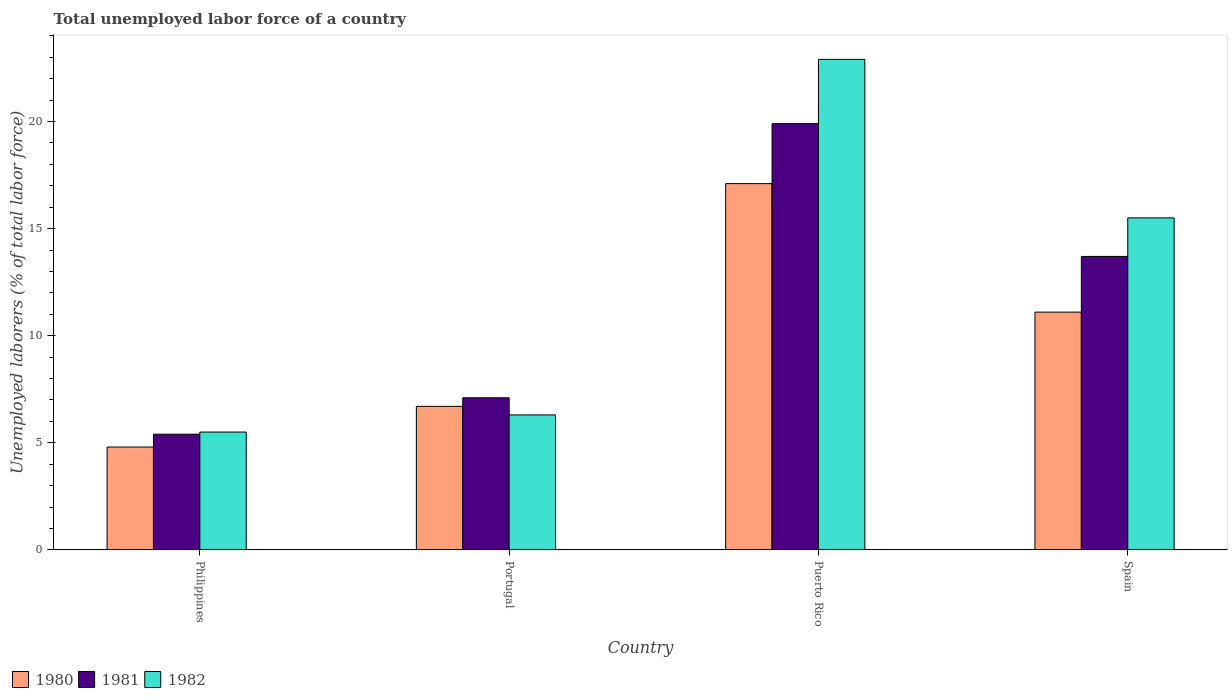How many different coloured bars are there?
Make the answer very short. 3. Are the number of bars on each tick of the X-axis equal?
Provide a short and direct response. Yes. How many bars are there on the 2nd tick from the left?
Your answer should be very brief. 3. What is the label of the 4th group of bars from the left?
Provide a short and direct response. Spain. In how many cases, is the number of bars for a given country not equal to the number of legend labels?
Make the answer very short. 0. Across all countries, what is the maximum total unemployed labor force in 1981?
Ensure brevity in your answer.  19.9. Across all countries, what is the minimum total unemployed labor force in 1980?
Provide a short and direct response. 4.8. In which country was the total unemployed labor force in 1981 maximum?
Ensure brevity in your answer.  Puerto Rico. In which country was the total unemployed labor force in 1981 minimum?
Keep it short and to the point. Philippines. What is the total total unemployed labor force in 1982 in the graph?
Your answer should be very brief. 50.2. What is the difference between the total unemployed labor force in 1980 in Portugal and that in Puerto Rico?
Provide a short and direct response. -10.4. What is the difference between the total unemployed labor force in 1980 in Philippines and the total unemployed labor force in 1981 in Portugal?
Make the answer very short. -2.3. What is the average total unemployed labor force in 1981 per country?
Make the answer very short. 11.52. What is the difference between the total unemployed labor force of/in 1982 and total unemployed labor force of/in 1981 in Spain?
Your answer should be very brief. 1.8. In how many countries, is the total unemployed labor force in 1980 greater than 12 %?
Ensure brevity in your answer.  1. What is the ratio of the total unemployed labor force in 1981 in Philippines to that in Puerto Rico?
Your answer should be compact. 0.27. Is the difference between the total unemployed labor force in 1982 in Philippines and Spain greater than the difference between the total unemployed labor force in 1981 in Philippines and Spain?
Offer a very short reply. No. What is the difference between the highest and the second highest total unemployed labor force in 1981?
Make the answer very short. 6.2. What is the difference between the highest and the lowest total unemployed labor force in 1981?
Provide a short and direct response. 14.5. What does the 3rd bar from the left in Portugal represents?
Make the answer very short. 1982. How many bars are there?
Ensure brevity in your answer.  12. Are all the bars in the graph horizontal?
Ensure brevity in your answer.  No. What is the difference between two consecutive major ticks on the Y-axis?
Give a very brief answer. 5. Are the values on the major ticks of Y-axis written in scientific E-notation?
Offer a terse response. No. Does the graph contain grids?
Provide a succinct answer. No. How many legend labels are there?
Keep it short and to the point. 3. How are the legend labels stacked?
Provide a succinct answer. Horizontal. What is the title of the graph?
Provide a short and direct response. Total unemployed labor force of a country. What is the label or title of the X-axis?
Make the answer very short. Country. What is the label or title of the Y-axis?
Ensure brevity in your answer.  Unemployed laborers (% of total labor force). What is the Unemployed laborers (% of total labor force) of 1980 in Philippines?
Offer a terse response. 4.8. What is the Unemployed laborers (% of total labor force) of 1981 in Philippines?
Offer a terse response. 5.4. What is the Unemployed laborers (% of total labor force) in 1980 in Portugal?
Make the answer very short. 6.7. What is the Unemployed laborers (% of total labor force) of 1981 in Portugal?
Your response must be concise. 7.1. What is the Unemployed laborers (% of total labor force) of 1982 in Portugal?
Your answer should be compact. 6.3. What is the Unemployed laborers (% of total labor force) in 1980 in Puerto Rico?
Provide a succinct answer. 17.1. What is the Unemployed laborers (% of total labor force) of 1981 in Puerto Rico?
Your answer should be compact. 19.9. What is the Unemployed laborers (% of total labor force) in 1982 in Puerto Rico?
Give a very brief answer. 22.9. What is the Unemployed laborers (% of total labor force) of 1980 in Spain?
Your response must be concise. 11.1. What is the Unemployed laborers (% of total labor force) in 1981 in Spain?
Your answer should be compact. 13.7. Across all countries, what is the maximum Unemployed laborers (% of total labor force) of 1980?
Your answer should be very brief. 17.1. Across all countries, what is the maximum Unemployed laborers (% of total labor force) of 1981?
Ensure brevity in your answer.  19.9. Across all countries, what is the maximum Unemployed laborers (% of total labor force) in 1982?
Your response must be concise. 22.9. Across all countries, what is the minimum Unemployed laborers (% of total labor force) in 1980?
Offer a terse response. 4.8. Across all countries, what is the minimum Unemployed laborers (% of total labor force) in 1981?
Give a very brief answer. 5.4. What is the total Unemployed laborers (% of total labor force) in 1980 in the graph?
Your response must be concise. 39.7. What is the total Unemployed laborers (% of total labor force) in 1981 in the graph?
Your answer should be very brief. 46.1. What is the total Unemployed laborers (% of total labor force) of 1982 in the graph?
Keep it short and to the point. 50.2. What is the difference between the Unemployed laborers (% of total labor force) of 1980 in Philippines and that in Portugal?
Make the answer very short. -1.9. What is the difference between the Unemployed laborers (% of total labor force) of 1981 in Philippines and that in Portugal?
Give a very brief answer. -1.7. What is the difference between the Unemployed laborers (% of total labor force) in 1981 in Philippines and that in Puerto Rico?
Your answer should be very brief. -14.5. What is the difference between the Unemployed laborers (% of total labor force) of 1982 in Philippines and that in Puerto Rico?
Offer a very short reply. -17.4. What is the difference between the Unemployed laborers (% of total labor force) of 1980 in Philippines and that in Spain?
Ensure brevity in your answer.  -6.3. What is the difference between the Unemployed laborers (% of total labor force) in 1980 in Portugal and that in Puerto Rico?
Offer a very short reply. -10.4. What is the difference between the Unemployed laborers (% of total labor force) in 1982 in Portugal and that in Puerto Rico?
Provide a succinct answer. -16.6. What is the difference between the Unemployed laborers (% of total labor force) of 1980 in Portugal and that in Spain?
Provide a short and direct response. -4.4. What is the difference between the Unemployed laborers (% of total labor force) in 1981 in Portugal and that in Spain?
Provide a succinct answer. -6.6. What is the difference between the Unemployed laborers (% of total labor force) in 1980 in Puerto Rico and that in Spain?
Your answer should be compact. 6. What is the difference between the Unemployed laborers (% of total labor force) of 1981 in Puerto Rico and that in Spain?
Your response must be concise. 6.2. What is the difference between the Unemployed laborers (% of total labor force) of 1982 in Puerto Rico and that in Spain?
Ensure brevity in your answer.  7.4. What is the difference between the Unemployed laborers (% of total labor force) in 1980 in Philippines and the Unemployed laborers (% of total labor force) in 1981 in Puerto Rico?
Your answer should be compact. -15.1. What is the difference between the Unemployed laborers (% of total labor force) of 1980 in Philippines and the Unemployed laborers (% of total labor force) of 1982 in Puerto Rico?
Offer a terse response. -18.1. What is the difference between the Unemployed laborers (% of total labor force) of 1981 in Philippines and the Unemployed laborers (% of total labor force) of 1982 in Puerto Rico?
Your response must be concise. -17.5. What is the difference between the Unemployed laborers (% of total labor force) of 1980 in Philippines and the Unemployed laborers (% of total labor force) of 1981 in Spain?
Provide a succinct answer. -8.9. What is the difference between the Unemployed laborers (% of total labor force) of 1980 in Philippines and the Unemployed laborers (% of total labor force) of 1982 in Spain?
Offer a terse response. -10.7. What is the difference between the Unemployed laborers (% of total labor force) of 1981 in Philippines and the Unemployed laborers (% of total labor force) of 1982 in Spain?
Your response must be concise. -10.1. What is the difference between the Unemployed laborers (% of total labor force) in 1980 in Portugal and the Unemployed laborers (% of total labor force) in 1981 in Puerto Rico?
Offer a very short reply. -13.2. What is the difference between the Unemployed laborers (% of total labor force) in 1980 in Portugal and the Unemployed laborers (% of total labor force) in 1982 in Puerto Rico?
Your response must be concise. -16.2. What is the difference between the Unemployed laborers (% of total labor force) of 1981 in Portugal and the Unemployed laborers (% of total labor force) of 1982 in Puerto Rico?
Your response must be concise. -15.8. What is the difference between the Unemployed laborers (% of total labor force) of 1980 in Portugal and the Unemployed laborers (% of total labor force) of 1981 in Spain?
Your answer should be very brief. -7. What is the difference between the Unemployed laborers (% of total labor force) in 1981 in Portugal and the Unemployed laborers (% of total labor force) in 1982 in Spain?
Your response must be concise. -8.4. What is the difference between the Unemployed laborers (% of total labor force) of 1980 in Puerto Rico and the Unemployed laborers (% of total labor force) of 1981 in Spain?
Make the answer very short. 3.4. What is the average Unemployed laborers (% of total labor force) in 1980 per country?
Provide a succinct answer. 9.93. What is the average Unemployed laborers (% of total labor force) in 1981 per country?
Offer a very short reply. 11.53. What is the average Unemployed laborers (% of total labor force) in 1982 per country?
Provide a short and direct response. 12.55. What is the difference between the Unemployed laborers (% of total labor force) of 1980 and Unemployed laborers (% of total labor force) of 1981 in Philippines?
Provide a succinct answer. -0.6. What is the difference between the Unemployed laborers (% of total labor force) of 1980 and Unemployed laborers (% of total labor force) of 1982 in Philippines?
Offer a terse response. -0.7. What is the difference between the Unemployed laborers (% of total labor force) of 1981 and Unemployed laborers (% of total labor force) of 1982 in Philippines?
Your answer should be compact. -0.1. What is the difference between the Unemployed laborers (% of total labor force) in 1981 and Unemployed laborers (% of total labor force) in 1982 in Puerto Rico?
Ensure brevity in your answer.  -3. What is the difference between the Unemployed laborers (% of total labor force) in 1981 and Unemployed laborers (% of total labor force) in 1982 in Spain?
Your response must be concise. -1.8. What is the ratio of the Unemployed laborers (% of total labor force) in 1980 in Philippines to that in Portugal?
Provide a short and direct response. 0.72. What is the ratio of the Unemployed laborers (% of total labor force) of 1981 in Philippines to that in Portugal?
Provide a short and direct response. 0.76. What is the ratio of the Unemployed laborers (% of total labor force) of 1982 in Philippines to that in Portugal?
Your answer should be very brief. 0.87. What is the ratio of the Unemployed laborers (% of total labor force) in 1980 in Philippines to that in Puerto Rico?
Your response must be concise. 0.28. What is the ratio of the Unemployed laborers (% of total labor force) of 1981 in Philippines to that in Puerto Rico?
Give a very brief answer. 0.27. What is the ratio of the Unemployed laborers (% of total labor force) in 1982 in Philippines to that in Puerto Rico?
Offer a terse response. 0.24. What is the ratio of the Unemployed laborers (% of total labor force) in 1980 in Philippines to that in Spain?
Your answer should be very brief. 0.43. What is the ratio of the Unemployed laborers (% of total labor force) of 1981 in Philippines to that in Spain?
Make the answer very short. 0.39. What is the ratio of the Unemployed laborers (% of total labor force) in 1982 in Philippines to that in Spain?
Ensure brevity in your answer.  0.35. What is the ratio of the Unemployed laborers (% of total labor force) of 1980 in Portugal to that in Puerto Rico?
Your answer should be compact. 0.39. What is the ratio of the Unemployed laborers (% of total labor force) in 1981 in Portugal to that in Puerto Rico?
Offer a terse response. 0.36. What is the ratio of the Unemployed laborers (% of total labor force) in 1982 in Portugal to that in Puerto Rico?
Keep it short and to the point. 0.28. What is the ratio of the Unemployed laborers (% of total labor force) of 1980 in Portugal to that in Spain?
Your answer should be compact. 0.6. What is the ratio of the Unemployed laborers (% of total labor force) of 1981 in Portugal to that in Spain?
Provide a short and direct response. 0.52. What is the ratio of the Unemployed laborers (% of total labor force) in 1982 in Portugal to that in Spain?
Provide a succinct answer. 0.41. What is the ratio of the Unemployed laborers (% of total labor force) in 1980 in Puerto Rico to that in Spain?
Offer a very short reply. 1.54. What is the ratio of the Unemployed laborers (% of total labor force) of 1981 in Puerto Rico to that in Spain?
Your answer should be very brief. 1.45. What is the ratio of the Unemployed laborers (% of total labor force) in 1982 in Puerto Rico to that in Spain?
Provide a short and direct response. 1.48. What is the difference between the highest and the second highest Unemployed laborers (% of total labor force) in 1981?
Provide a succinct answer. 6.2. What is the difference between the highest and the second highest Unemployed laborers (% of total labor force) in 1982?
Provide a short and direct response. 7.4. What is the difference between the highest and the lowest Unemployed laborers (% of total labor force) in 1980?
Make the answer very short. 12.3. What is the difference between the highest and the lowest Unemployed laborers (% of total labor force) of 1981?
Keep it short and to the point. 14.5. What is the difference between the highest and the lowest Unemployed laborers (% of total labor force) of 1982?
Your answer should be very brief. 17.4. 